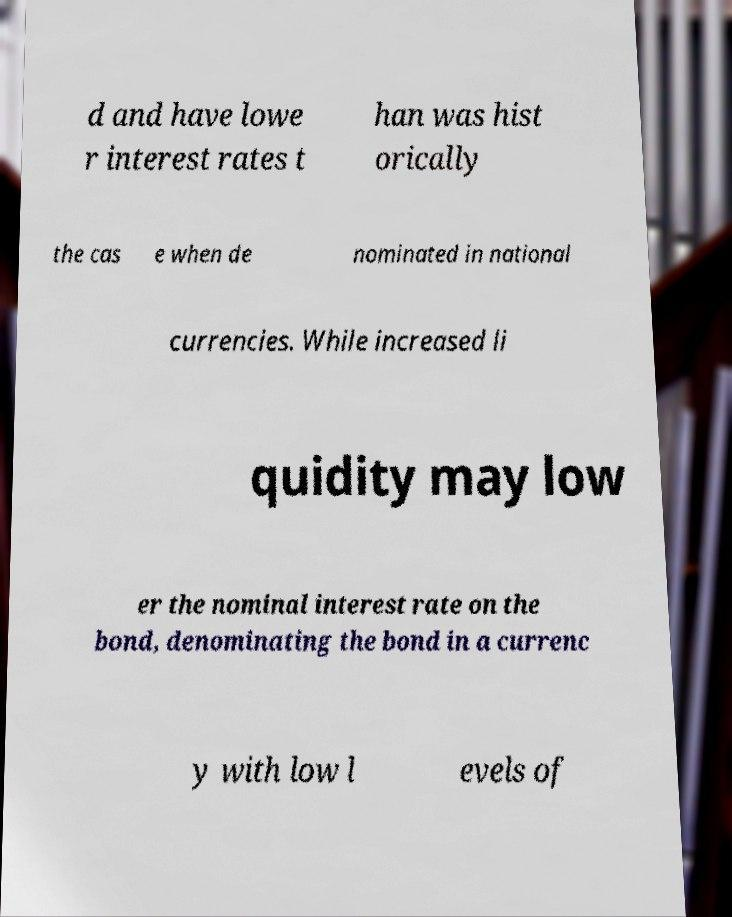I need the written content from this picture converted into text. Can you do that? d and have lowe r interest rates t han was hist orically the cas e when de nominated in national currencies. While increased li quidity may low er the nominal interest rate on the bond, denominating the bond in a currenc y with low l evels of 